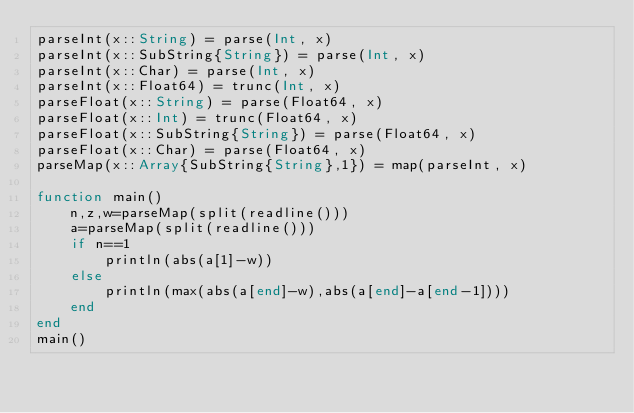<code> <loc_0><loc_0><loc_500><loc_500><_Julia_>parseInt(x::String) = parse(Int, x)
parseInt(x::SubString{String}) = parse(Int, x)
parseInt(x::Char) = parse(Int, x)
parseInt(x::Float64) = trunc(Int, x)
parseFloat(x::String) = parse(Float64, x)
parseFloat(x::Int) = trunc(Float64, x)
parseFloat(x::SubString{String}) = parse(Float64, x)
parseFloat(x::Char) = parse(Float64, x)
parseMap(x::Array{SubString{String},1}) = map(parseInt, x)

function main()
    n,z,w=parseMap(split(readline()))
    a=parseMap(split(readline()))
    if n==1
        println(abs(a[1]-w))
    else
        println(max(abs(a[end]-w),abs(a[end]-a[end-1])))
    end
end
main()</code> 